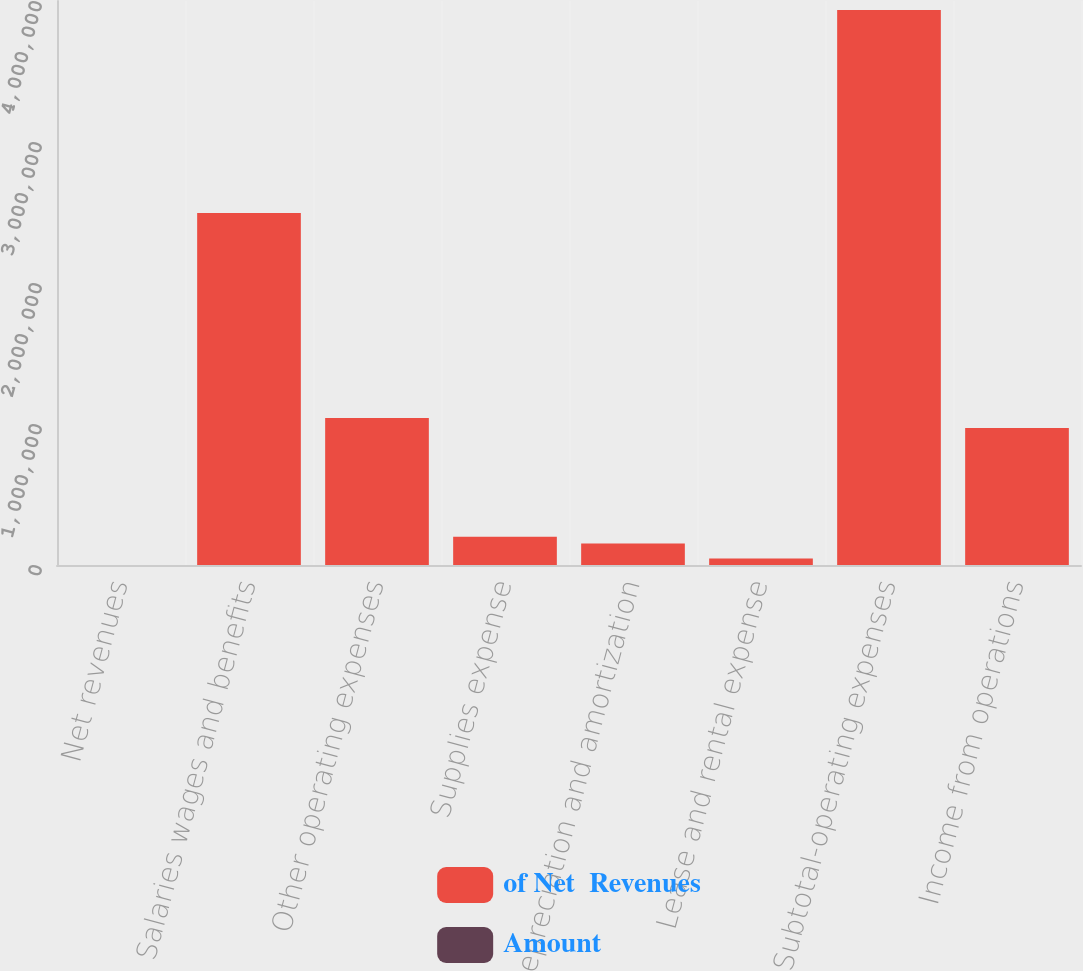Convert chart. <chart><loc_0><loc_0><loc_500><loc_500><stacked_bar_chart><ecel><fcel>Net revenues<fcel>Salaries wages and benefits<fcel>Other operating expenses<fcel>Supplies expense<fcel>Depreciation and amortization<fcel>Lease and rental expense<fcel>Subtotal-operating expenses<fcel>Income from operations<nl><fcel>of Net  Revenues<fcel>100<fcel>2.49624e+06<fcel>1.04206e+06<fcel>199936<fcel>152067<fcel>45445<fcel>3.93574e+06<fcel>970979<nl><fcel>Amount<fcel>100<fcel>50.9<fcel>21.2<fcel>4.1<fcel>3.1<fcel>0.9<fcel>80.2<fcel>19.8<nl></chart> 